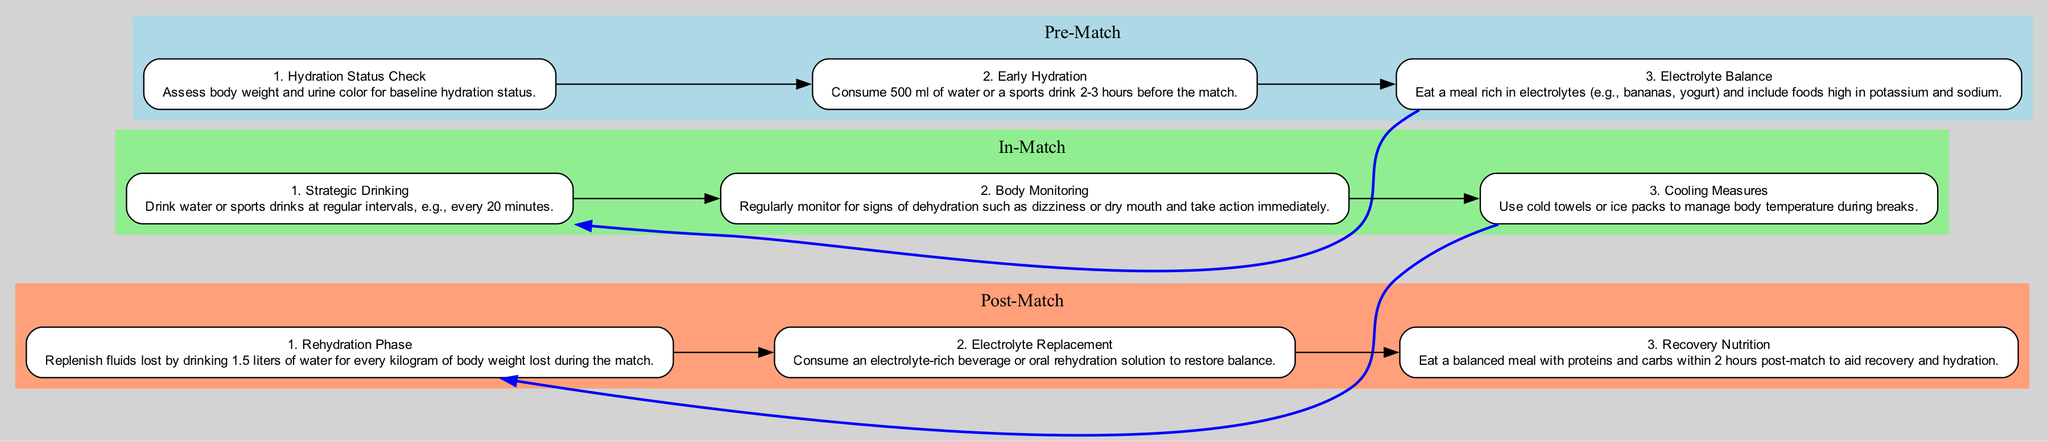What's the first step in the Pre-Match Hydration Protocol? The first step listed in the Pre-Match section is to "Assess body weight and urine color for baseline hydration status." This is clearly indicated as the first action required before the match begins.
Answer: Assess body weight and urine color for baseline hydration status How often should players drink water or sports drinks during the match? According to the In-Match Hydration Protocol, players should drink water or sports drinks at regular intervals, specifically every 20 minutes. This information is stated in the second step of the In-Match section.
Answer: Every 20 minutes What is consumed for electrolyte balance before the match? The Pre-Match Hydration Protocol advises athletes to eat a meal rich in electrolytes, mentioning foods like bananas and yogurt that are high in potassium and sodium. This makes it clear which food types are recommended.
Answer: A meal rich in electrolytes What is the total fluid intake recommended during the Rehydration Phase? The Rehydration Phase specified in the Post-Match protocol states that players should replenish fluids by drinking 1.5 liters of water for every kilogram of body weight lost during the match. This provides a specific equation for fluid intake.
Answer: 1.5 liters for every kilogram lost What actions are suggested to monitor hydration status during the match? The document suggests that during the match, players should regularly monitor for signs of dehydration such as dizziness or dry mouth and take action immediately if these signs occur. This indicates the need for constant assessment.
Answer: Monitor for signs of dehydration How does the Pre-Match phase connect to the In-Match phase? The connection is established by the directive that after the last Pre-Match step (Electrolyte Balance), the flow moves directly to the first In-Match step (Strategic Drinking), making it clear that preparation leads to active hydration during the game.
Answer: From Electrolyte Balance to Strategic Drinking What is the goal of the Post-Match Hydration Protocol? The primary goal outlined in the Post-Match section is to aid recovery and hydration, as indicated by consuming a balanced meal with proteins and carbohydrates within 2 hours after the match, supporting overall replenishment.
Answer: Aid recovery and hydration How is body temperature managed during the match? The In-Match protocol specifies that players should use cold towels or ice packs during breaks to manage their body temperature. This gives a clear method for effective cooling strategies during gameplay.
Answer: Use cold towels or ice packs 